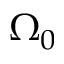<formula> <loc_0><loc_0><loc_500><loc_500>\Omega _ { 0 }</formula> 